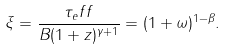<formula> <loc_0><loc_0><loc_500><loc_500>\xi = \frac { \tau _ { e } f f } { B ( 1 + z ) ^ { \gamma + 1 } } = ( 1 + \omega ) ^ { 1 - \beta } .</formula> 